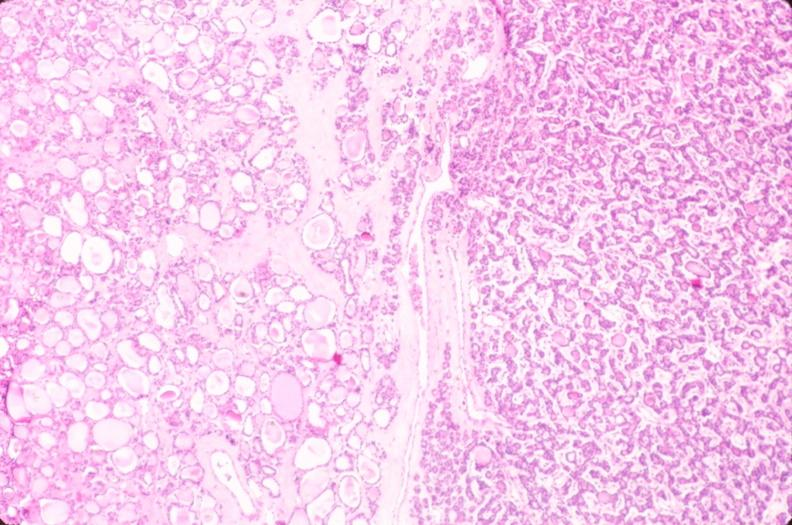does atherosclerosis show thyroid, nodular hyperplasia?
Answer the question using a single word or phrase. No 